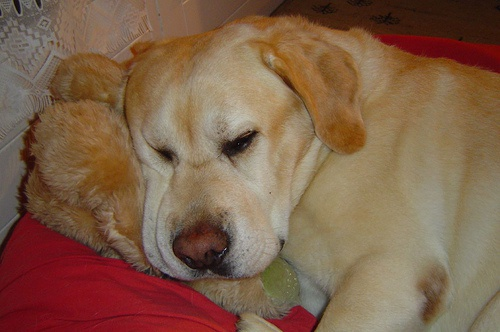Describe the objects in this image and their specific colors. I can see dog in gray, maroon, and darkgray tones, teddy bear in gray, maroon, and olive tones, and couch in gray, maroon, brown, and black tones in this image. 